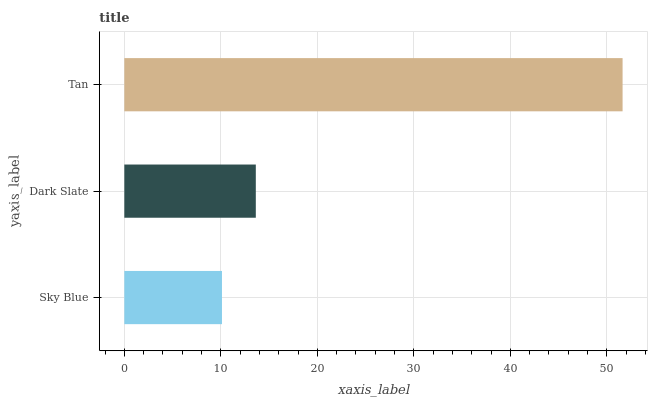Is Sky Blue the minimum?
Answer yes or no. Yes. Is Tan the maximum?
Answer yes or no. Yes. Is Dark Slate the minimum?
Answer yes or no. No. Is Dark Slate the maximum?
Answer yes or no. No. Is Dark Slate greater than Sky Blue?
Answer yes or no. Yes. Is Sky Blue less than Dark Slate?
Answer yes or no. Yes. Is Sky Blue greater than Dark Slate?
Answer yes or no. No. Is Dark Slate less than Sky Blue?
Answer yes or no. No. Is Dark Slate the high median?
Answer yes or no. Yes. Is Dark Slate the low median?
Answer yes or no. Yes. Is Sky Blue the high median?
Answer yes or no. No. Is Sky Blue the low median?
Answer yes or no. No. 